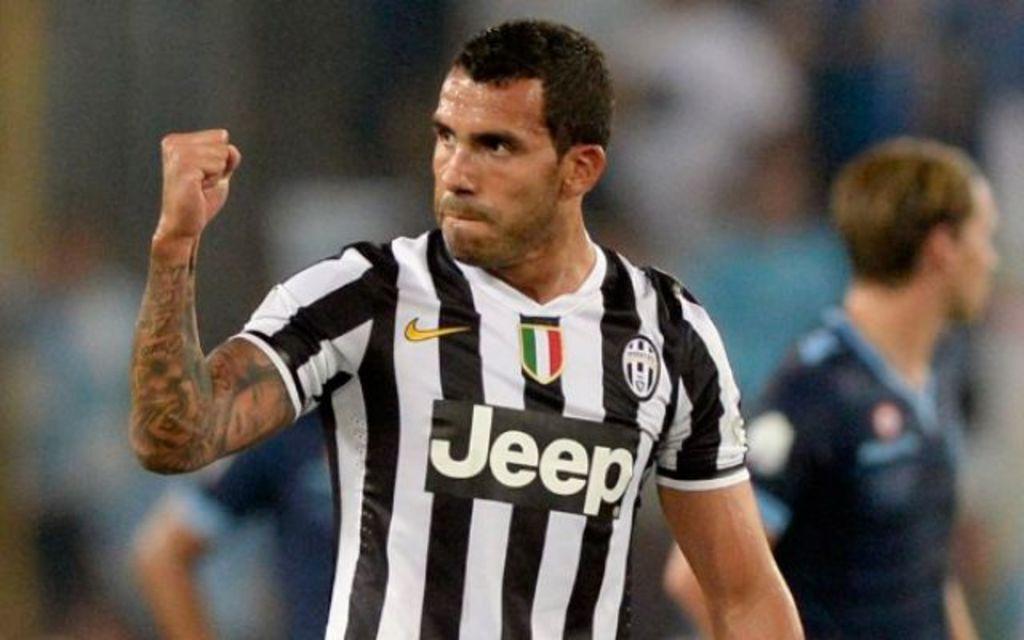What does his shirt say?
Your answer should be very brief. Jeep. 